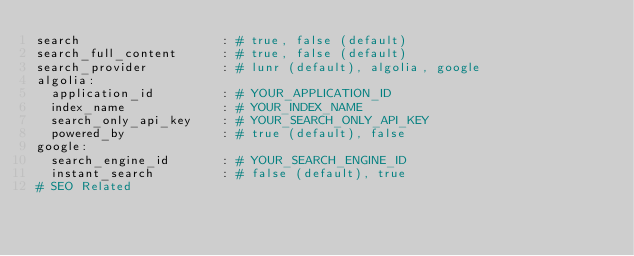<code> <loc_0><loc_0><loc_500><loc_500><_YAML_>search                   : # true, false (default)
search_full_content      : # true, false (default)
search_provider          : # lunr (default), algolia, google
algolia:
  application_id         : # YOUR_APPLICATION_ID
  index_name             : # YOUR_INDEX_NAME
  search_only_api_key    : # YOUR_SEARCH_ONLY_API_KEY
  powered_by             : # true (default), false
google:
  search_engine_id       : # YOUR_SEARCH_ENGINE_ID
  instant_search         : # false (default), true
# SEO Related</code> 